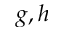Convert formula to latex. <formula><loc_0><loc_0><loc_500><loc_500>g , h</formula> 